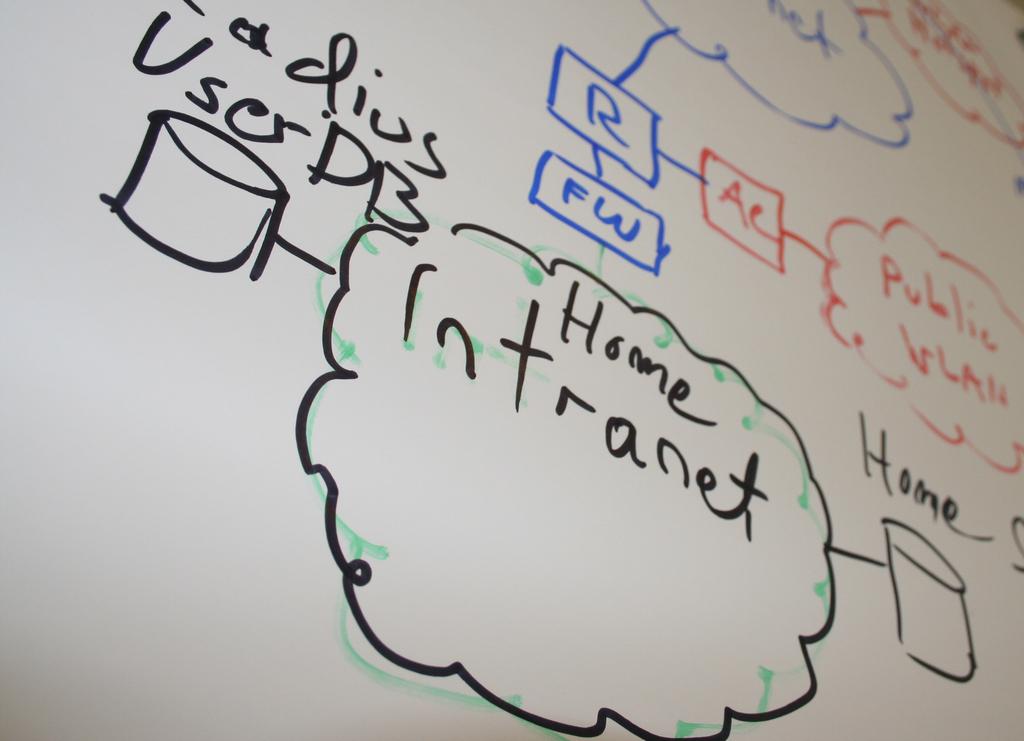What does the can on the right represent ?
Provide a succinct answer. Home. 